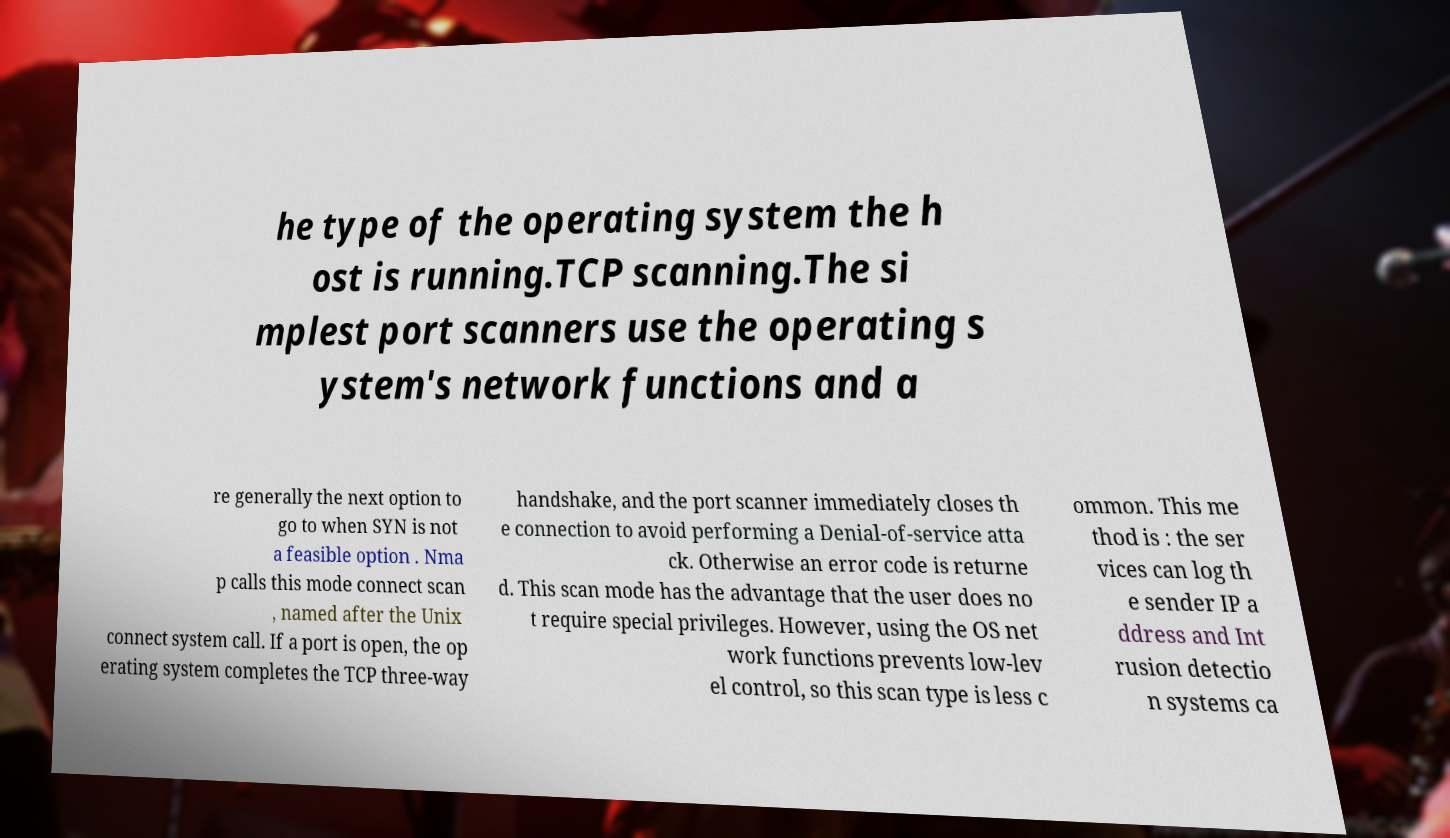Could you assist in decoding the text presented in this image and type it out clearly? he type of the operating system the h ost is running.TCP scanning.The si mplest port scanners use the operating s ystem's network functions and a re generally the next option to go to when SYN is not a feasible option . Nma p calls this mode connect scan , named after the Unix connect system call. If a port is open, the op erating system completes the TCP three-way handshake, and the port scanner immediately closes th e connection to avoid performing a Denial-of-service atta ck. Otherwise an error code is returne d. This scan mode has the advantage that the user does no t require special privileges. However, using the OS net work functions prevents low-lev el control, so this scan type is less c ommon. This me thod is : the ser vices can log th e sender IP a ddress and Int rusion detectio n systems ca 